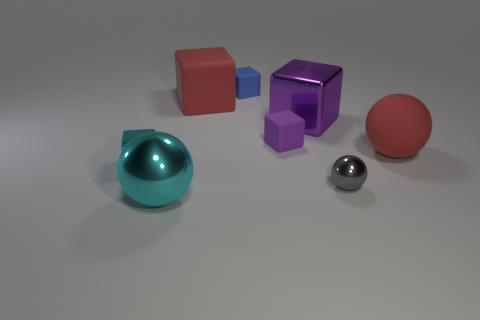Are there any other small cyan things that have the same shape as the small cyan object?
Offer a very short reply. No. Do the large purple thing and the small rubber thing that is on the right side of the blue rubber object have the same shape?
Your answer should be very brief. Yes. What number of cylinders are either tiny cyan metallic things or gray things?
Your response must be concise. 0. There is a red object right of the gray object; what is its shape?
Give a very brief answer. Sphere. How many tiny green balls have the same material as the small blue thing?
Your response must be concise. 0. Is the number of small blue things to the right of the red block less than the number of large cyan objects?
Keep it short and to the point. No. How big is the cyan thing that is left of the metal ball in front of the tiny gray object?
Offer a very short reply. Small. Is the color of the small ball the same as the sphere to the left of the blue rubber block?
Your answer should be very brief. No. What material is the purple cube that is the same size as the cyan sphere?
Keep it short and to the point. Metal. Are there fewer small metallic things right of the blue rubber cube than purple things on the right side of the big metallic block?
Keep it short and to the point. No. 